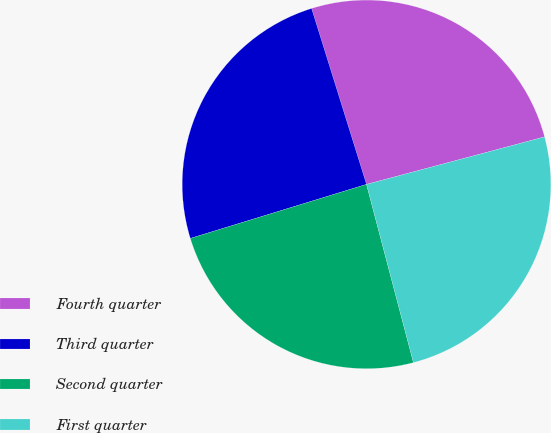Convert chart to OTSL. <chart><loc_0><loc_0><loc_500><loc_500><pie_chart><fcel>Fourth quarter<fcel>Third quarter<fcel>Second quarter<fcel>First quarter<nl><fcel>25.67%<fcel>24.92%<fcel>24.36%<fcel>25.05%<nl></chart> 